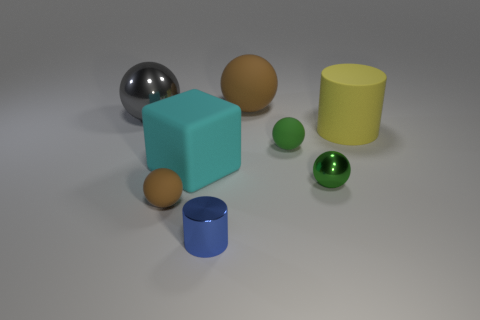Is the size of the shiny ball on the left side of the green matte object the same as the blue shiny cylinder?
Your response must be concise. No. There is a object in front of the small rubber ball left of the cyan matte thing; what number of small matte objects are to the right of it?
Offer a very short reply. 1. What number of red things are large metallic things or metal spheres?
Give a very brief answer. 0. The big ball that is made of the same material as the cyan thing is what color?
Your answer should be compact. Brown. Is there any other thing that has the same size as the rubber cube?
Offer a terse response. Yes. What number of large objects are either cyan rubber cubes or yellow shiny cylinders?
Provide a short and direct response. 1. Is the number of big rubber things less than the number of blue shiny things?
Your answer should be very brief. No. What color is the other thing that is the same shape as the blue thing?
Provide a short and direct response. Yellow. Is there any other thing that has the same shape as the big brown object?
Your response must be concise. Yes. Is the number of big shiny cylinders greater than the number of large rubber cylinders?
Your answer should be compact. No. 